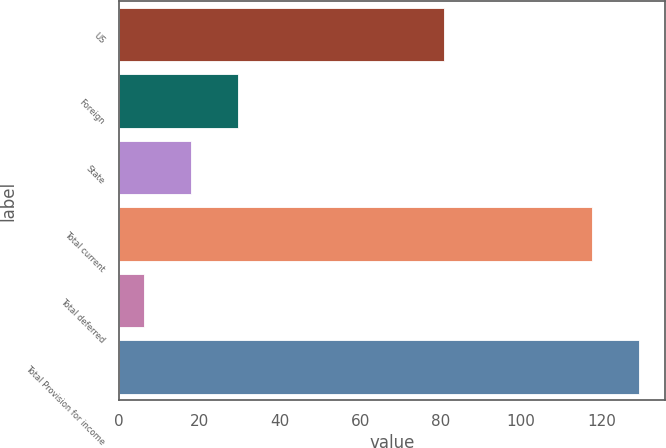<chart> <loc_0><loc_0><loc_500><loc_500><bar_chart><fcel>US<fcel>Foreign<fcel>State<fcel>Total current<fcel>Total deferred<fcel>Total Provision for income<nl><fcel>80.8<fcel>29.62<fcel>17.86<fcel>117.6<fcel>6.1<fcel>129.36<nl></chart> 